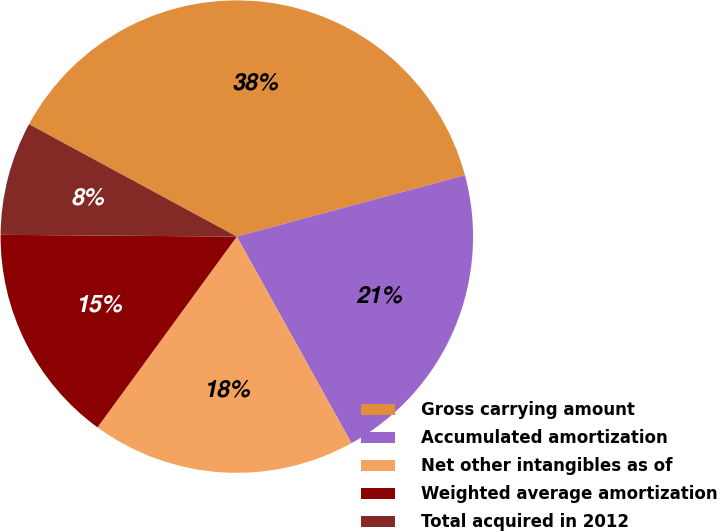Convert chart. <chart><loc_0><loc_0><loc_500><loc_500><pie_chart><fcel>Gross carrying amount<fcel>Accumulated amortization<fcel>Net other intangibles as of<fcel>Weighted average amortization<fcel>Total acquired in 2012<nl><fcel>37.93%<fcel>21.12%<fcel>18.1%<fcel>15.08%<fcel>7.77%<nl></chart> 